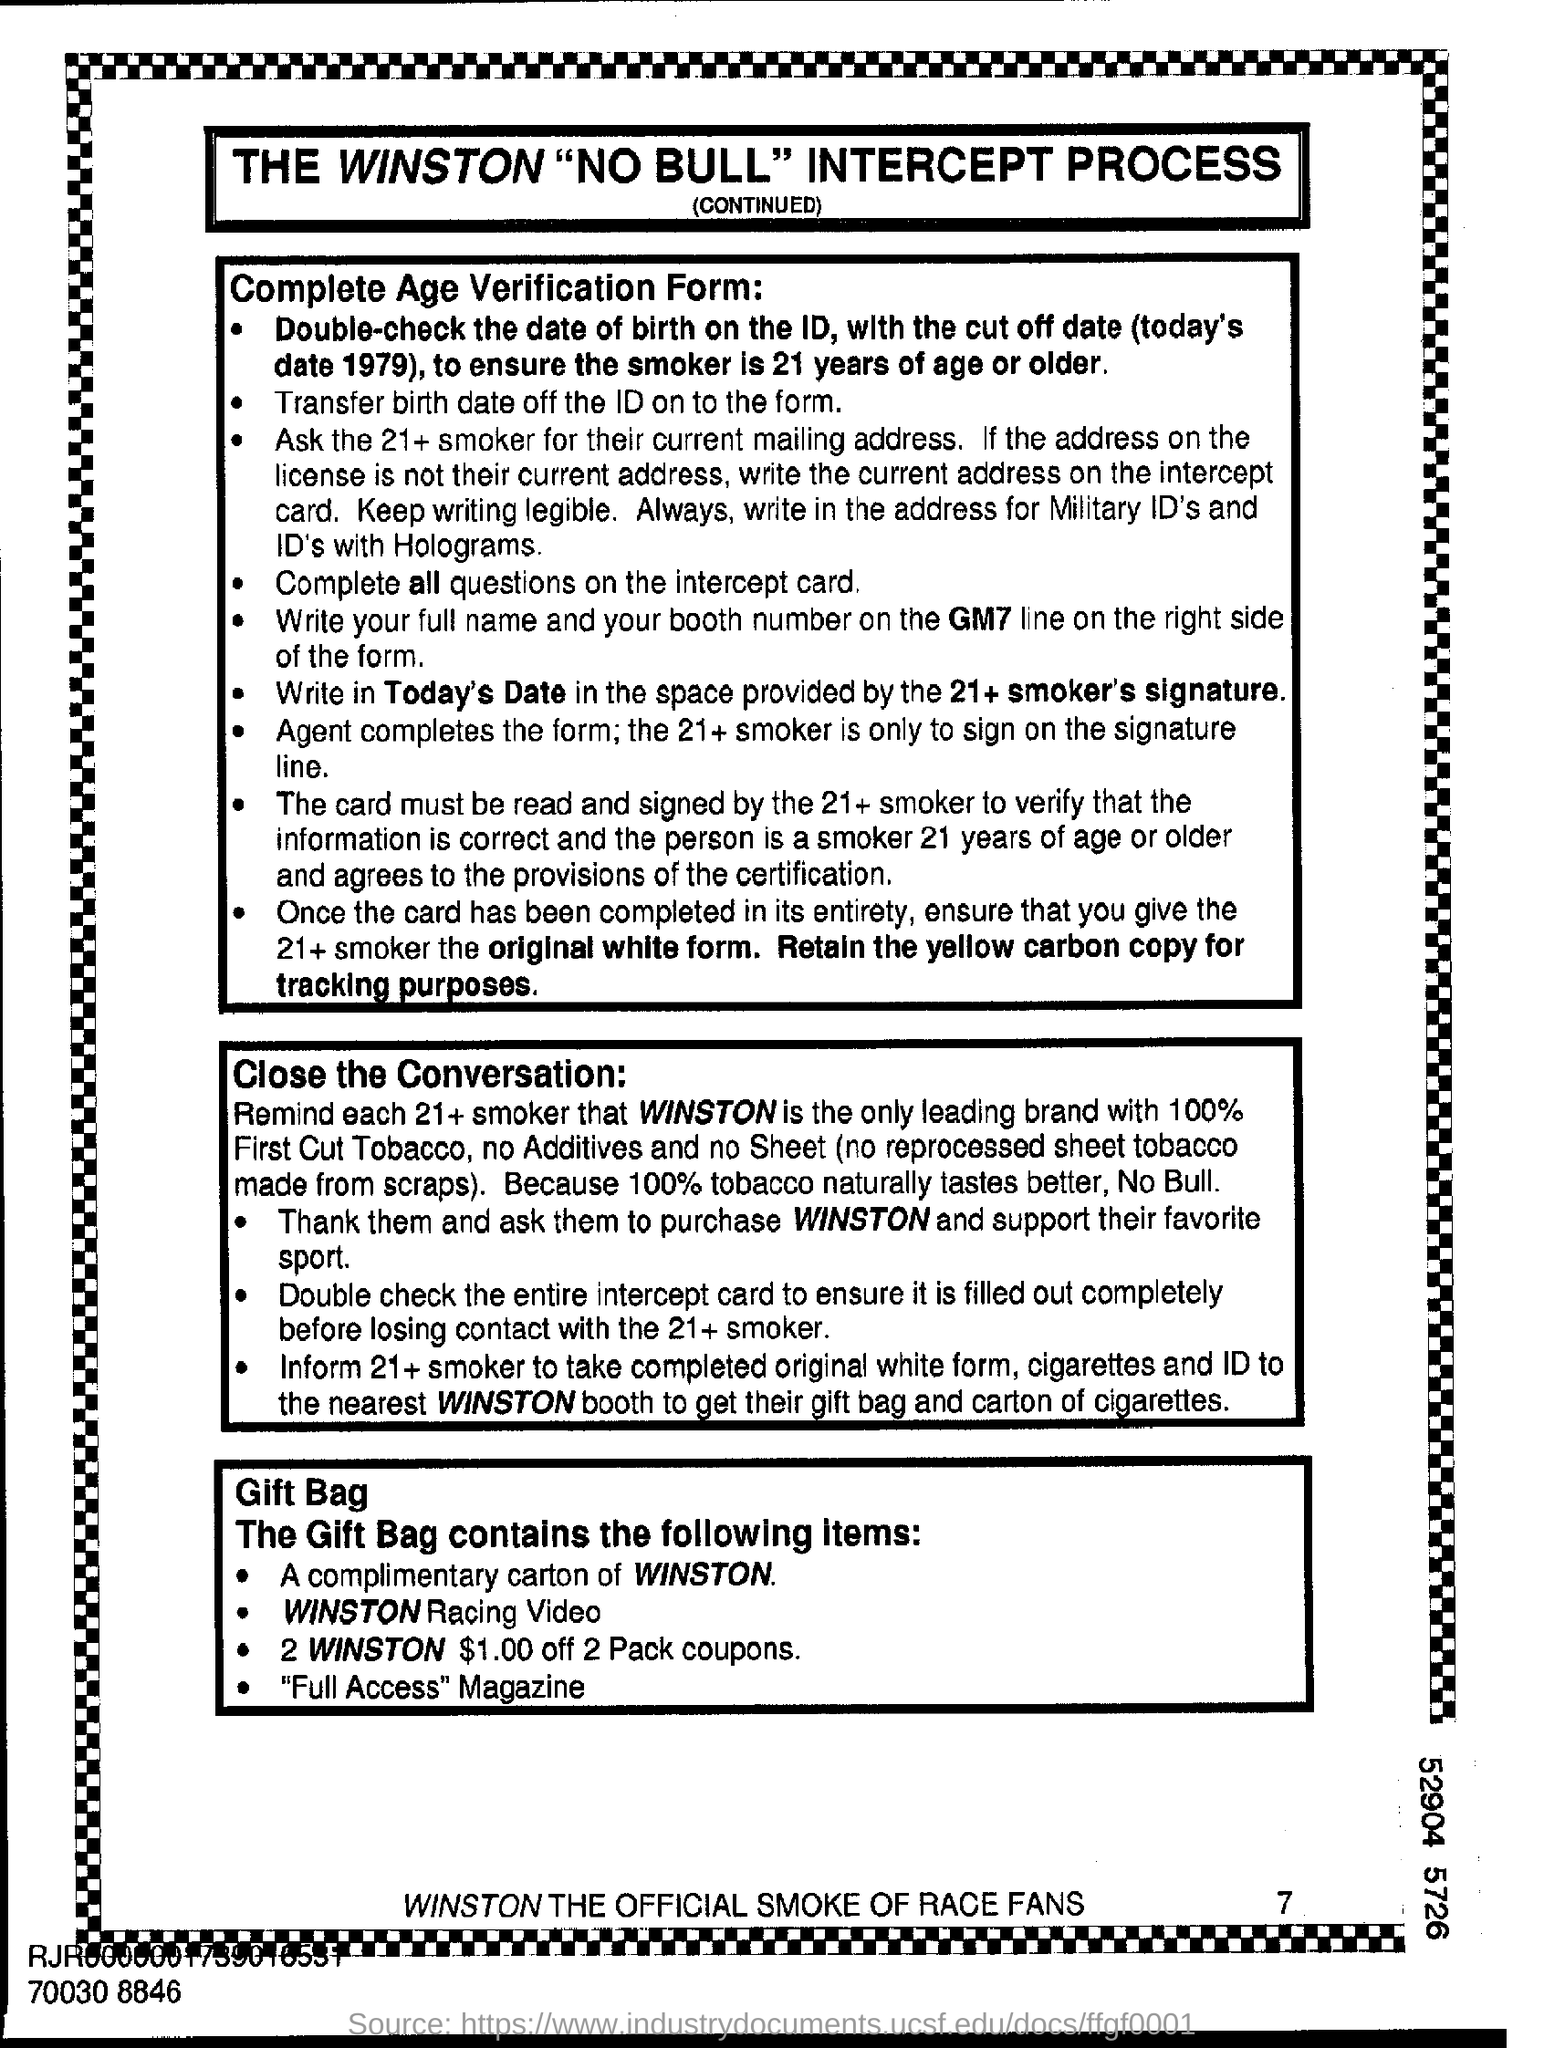Give some essential details in this illustration. The gift bag contains a magazine labeled 'Full Access'. 